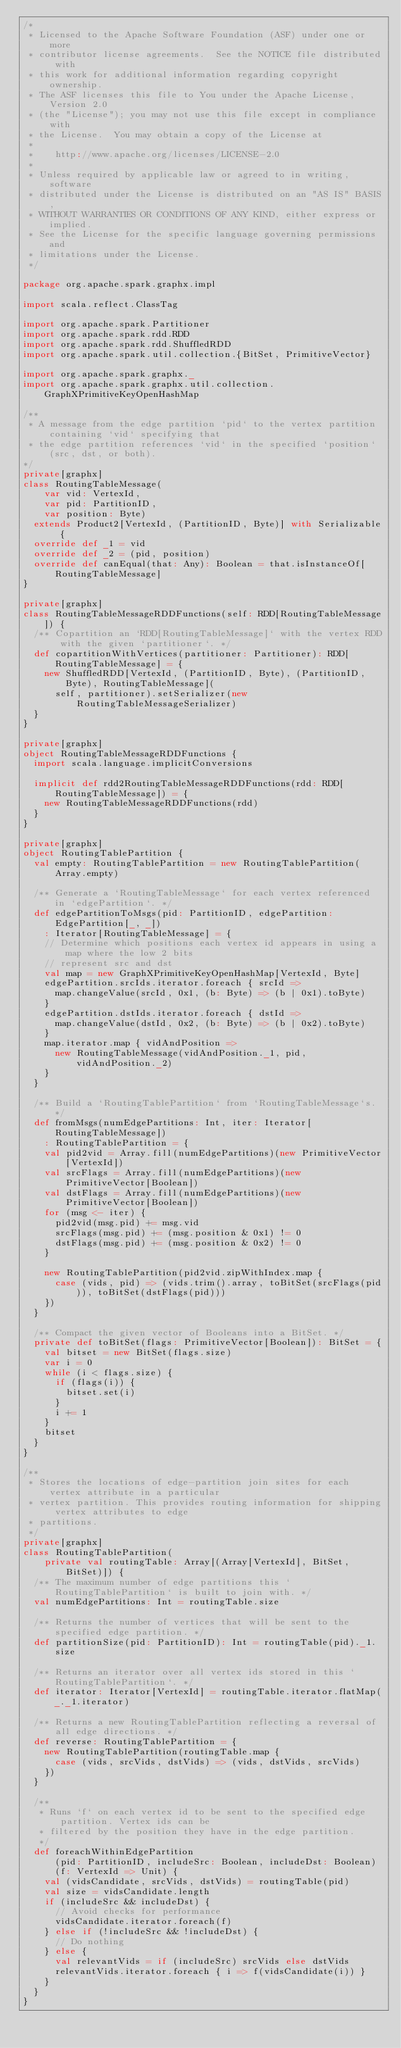Convert code to text. <code><loc_0><loc_0><loc_500><loc_500><_Scala_>/*
 * Licensed to the Apache Software Foundation (ASF) under one or more
 * contributor license agreements.  See the NOTICE file distributed with
 * this work for additional information regarding copyright ownership.
 * The ASF licenses this file to You under the Apache License, Version 2.0
 * (the "License"); you may not use this file except in compliance with
 * the License.  You may obtain a copy of the License at
 *
 *    http://www.apache.org/licenses/LICENSE-2.0
 *
 * Unless required by applicable law or agreed to in writing, software
 * distributed under the License is distributed on an "AS IS" BASIS,
 * WITHOUT WARRANTIES OR CONDITIONS OF ANY KIND, either express or implied.
 * See the License for the specific language governing permissions and
 * limitations under the License.
 */

package org.apache.spark.graphx.impl

import scala.reflect.ClassTag

import org.apache.spark.Partitioner
import org.apache.spark.rdd.RDD
import org.apache.spark.rdd.ShuffledRDD
import org.apache.spark.util.collection.{BitSet, PrimitiveVector}

import org.apache.spark.graphx._
import org.apache.spark.graphx.util.collection.GraphXPrimitiveKeyOpenHashMap

/**
 * A message from the edge partition `pid` to the vertex partition containing `vid` specifying that
 * the edge partition references `vid` in the specified `position` (src, dst, or both).
*/
private[graphx]
class RoutingTableMessage(
    var vid: VertexId,
    var pid: PartitionID,
    var position: Byte)
  extends Product2[VertexId, (PartitionID, Byte)] with Serializable {
  override def _1 = vid
  override def _2 = (pid, position)
  override def canEqual(that: Any): Boolean = that.isInstanceOf[RoutingTableMessage]
}

private[graphx]
class RoutingTableMessageRDDFunctions(self: RDD[RoutingTableMessage]) {
  /** Copartition an `RDD[RoutingTableMessage]` with the vertex RDD with the given `partitioner`. */
  def copartitionWithVertices(partitioner: Partitioner): RDD[RoutingTableMessage] = {
    new ShuffledRDD[VertexId, (PartitionID, Byte), (PartitionID, Byte), RoutingTableMessage](
      self, partitioner).setSerializer(new RoutingTableMessageSerializer)
  }
}

private[graphx]
object RoutingTableMessageRDDFunctions {
  import scala.language.implicitConversions

  implicit def rdd2RoutingTableMessageRDDFunctions(rdd: RDD[RoutingTableMessage]) = {
    new RoutingTableMessageRDDFunctions(rdd)
  }
}

private[graphx]
object RoutingTablePartition {
  val empty: RoutingTablePartition = new RoutingTablePartition(Array.empty)

  /** Generate a `RoutingTableMessage` for each vertex referenced in `edgePartition`. */
  def edgePartitionToMsgs(pid: PartitionID, edgePartition: EdgePartition[_, _])
    : Iterator[RoutingTableMessage] = {
    // Determine which positions each vertex id appears in using a map where the low 2 bits
    // represent src and dst
    val map = new GraphXPrimitiveKeyOpenHashMap[VertexId, Byte]
    edgePartition.srcIds.iterator.foreach { srcId =>
      map.changeValue(srcId, 0x1, (b: Byte) => (b | 0x1).toByte)
    }
    edgePartition.dstIds.iterator.foreach { dstId =>
      map.changeValue(dstId, 0x2, (b: Byte) => (b | 0x2).toByte)
    }
    map.iterator.map { vidAndPosition =>
      new RoutingTableMessage(vidAndPosition._1, pid, vidAndPosition._2)
    }
  }

  /** Build a `RoutingTablePartition` from `RoutingTableMessage`s. */
  def fromMsgs(numEdgePartitions: Int, iter: Iterator[RoutingTableMessage])
    : RoutingTablePartition = {
    val pid2vid = Array.fill(numEdgePartitions)(new PrimitiveVector[VertexId])
    val srcFlags = Array.fill(numEdgePartitions)(new PrimitiveVector[Boolean])
    val dstFlags = Array.fill(numEdgePartitions)(new PrimitiveVector[Boolean])
    for (msg <- iter) {
      pid2vid(msg.pid) += msg.vid
      srcFlags(msg.pid) += (msg.position & 0x1) != 0
      dstFlags(msg.pid) += (msg.position & 0x2) != 0
    }

    new RoutingTablePartition(pid2vid.zipWithIndex.map {
      case (vids, pid) => (vids.trim().array, toBitSet(srcFlags(pid)), toBitSet(dstFlags(pid)))
    })
  }

  /** Compact the given vector of Booleans into a BitSet. */
  private def toBitSet(flags: PrimitiveVector[Boolean]): BitSet = {
    val bitset = new BitSet(flags.size)
    var i = 0
    while (i < flags.size) {
      if (flags(i)) {
        bitset.set(i)
      }
      i += 1
    }
    bitset
  }
}

/**
 * Stores the locations of edge-partition join sites for each vertex attribute in a particular
 * vertex partition. This provides routing information for shipping vertex attributes to edge
 * partitions.
 */
private[graphx]
class RoutingTablePartition(
    private val routingTable: Array[(Array[VertexId], BitSet, BitSet)]) {
  /** The maximum number of edge partitions this `RoutingTablePartition` is built to join with. */
  val numEdgePartitions: Int = routingTable.size

  /** Returns the number of vertices that will be sent to the specified edge partition. */
  def partitionSize(pid: PartitionID): Int = routingTable(pid)._1.size

  /** Returns an iterator over all vertex ids stored in this `RoutingTablePartition`. */
  def iterator: Iterator[VertexId] = routingTable.iterator.flatMap(_._1.iterator)

  /** Returns a new RoutingTablePartition reflecting a reversal of all edge directions. */
  def reverse: RoutingTablePartition = {
    new RoutingTablePartition(routingTable.map {
      case (vids, srcVids, dstVids) => (vids, dstVids, srcVids)
    })
  }

  /**
   * Runs `f` on each vertex id to be sent to the specified edge partition. Vertex ids can be
   * filtered by the position they have in the edge partition.
   */
  def foreachWithinEdgePartition
      (pid: PartitionID, includeSrc: Boolean, includeDst: Boolean)
      (f: VertexId => Unit) {
    val (vidsCandidate, srcVids, dstVids) = routingTable(pid)
    val size = vidsCandidate.length
    if (includeSrc && includeDst) {
      // Avoid checks for performance
      vidsCandidate.iterator.foreach(f)
    } else if (!includeSrc && !includeDst) {
      // Do nothing
    } else {
      val relevantVids = if (includeSrc) srcVids else dstVids
      relevantVids.iterator.foreach { i => f(vidsCandidate(i)) }
    }
  }
}
</code> 